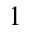<formula> <loc_0><loc_0><loc_500><loc_500>1</formula> 